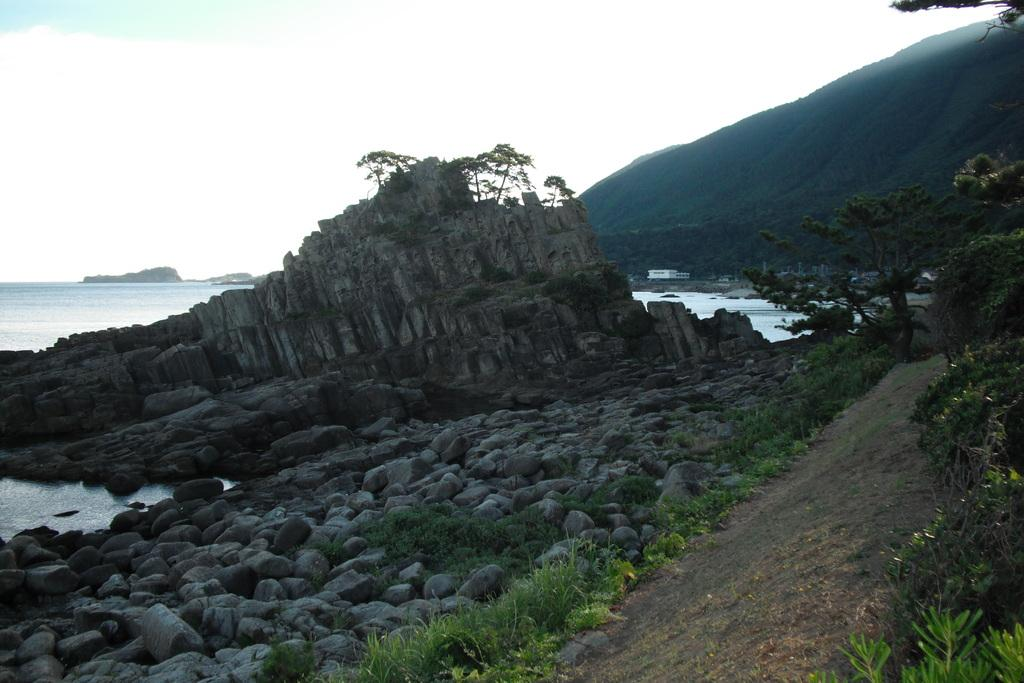What type of natural formation can be seen in the image? There are rocks in the image. Where are the rocks located? The rocks are at sea. What type of man-made structure is visible in the image? There is a building in the image. What type of landscape feature can be seen in the image? There are mountains in the image. What type of vegetation is present in the image? There is grass and trees in the image. Can you see any apples growing on the trees in the image? There is no mention of apples or trees with fruit in the provided facts, so we cannot determine if there are any apples in the image. Is the image set in space? No, the image is not set in space; it features rocks at sea, a building, mountains, grass, and trees. 